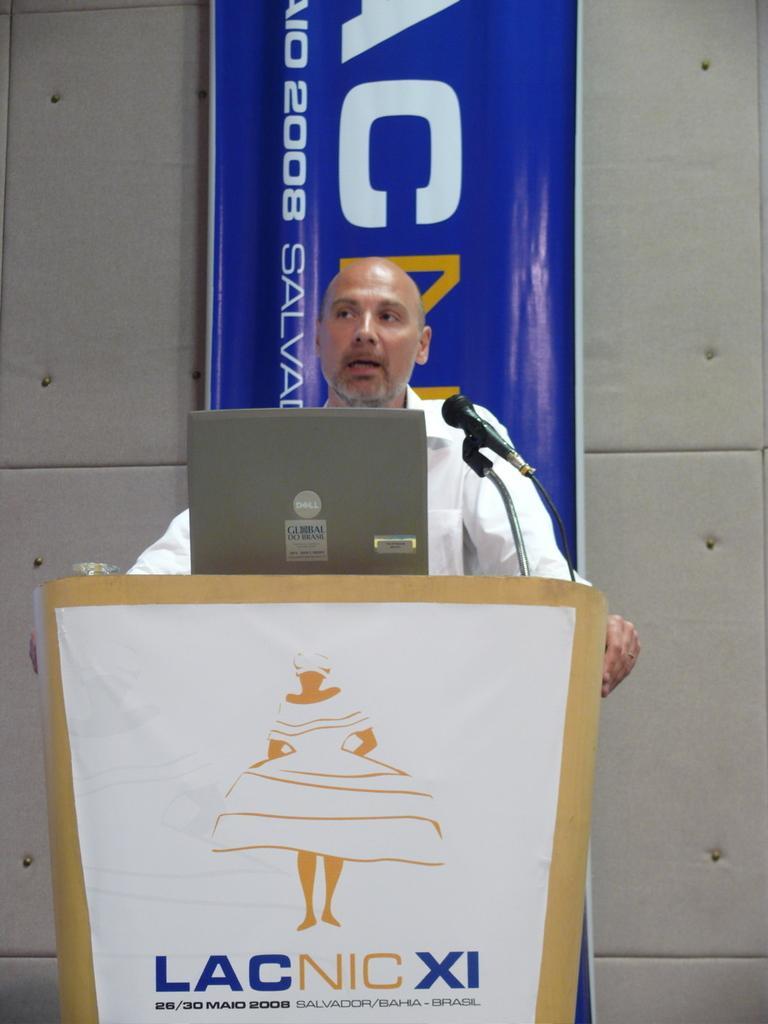How would you summarize this image in a sentence or two? In this image we can see one man standing, holding the podium and talking. There is one wooden podium, one object on the podium, one laptop on the podium, one mike with wire attached to the podium, one white banner with text and image attached to the podium. One blue color banner with text and numbers behind the man. It looks like a wall with small objects in the background. 